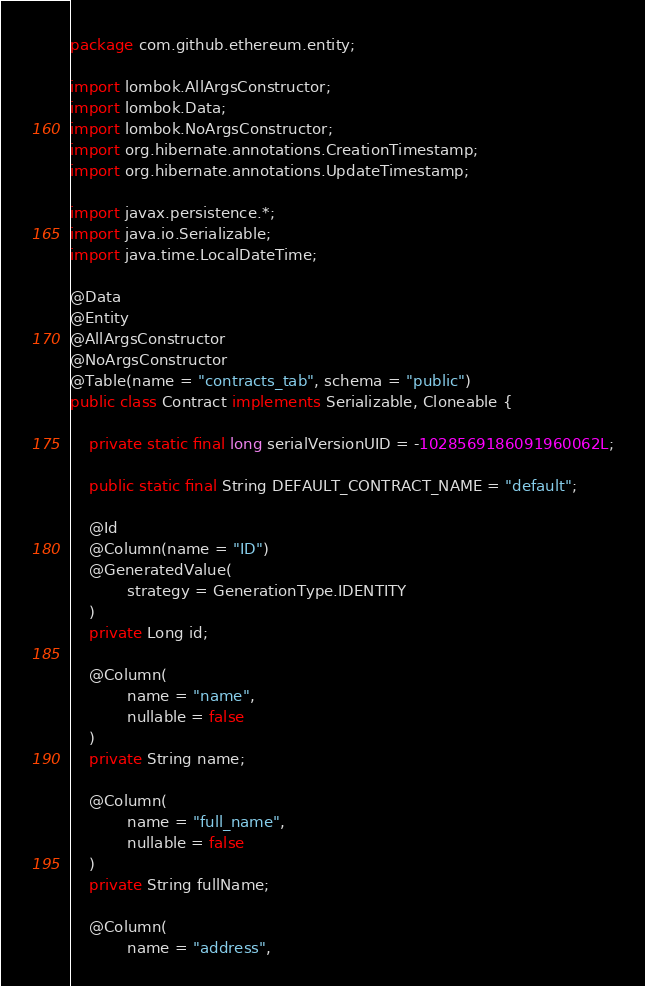<code> <loc_0><loc_0><loc_500><loc_500><_Java_>package com.github.ethereum.entity;

import lombok.AllArgsConstructor;
import lombok.Data;
import lombok.NoArgsConstructor;
import org.hibernate.annotations.CreationTimestamp;
import org.hibernate.annotations.UpdateTimestamp;

import javax.persistence.*;
import java.io.Serializable;
import java.time.LocalDateTime;

@Data
@Entity
@AllArgsConstructor
@NoArgsConstructor
@Table(name = "contracts_tab", schema = "public")
public class Contract implements Serializable, Cloneable {

    private static final long serialVersionUID = -1028569186091960062L;

    public static final String DEFAULT_CONTRACT_NAME = "default";

    @Id
    @Column(name = "ID")
    @GeneratedValue(
            strategy = GenerationType.IDENTITY
    )
    private Long id;

    @Column(
            name = "name",
            nullable = false
    )
    private String name;

    @Column(
            name = "full_name",
            nullable = false
    )
    private String fullName;

    @Column(
            name = "address",</code> 